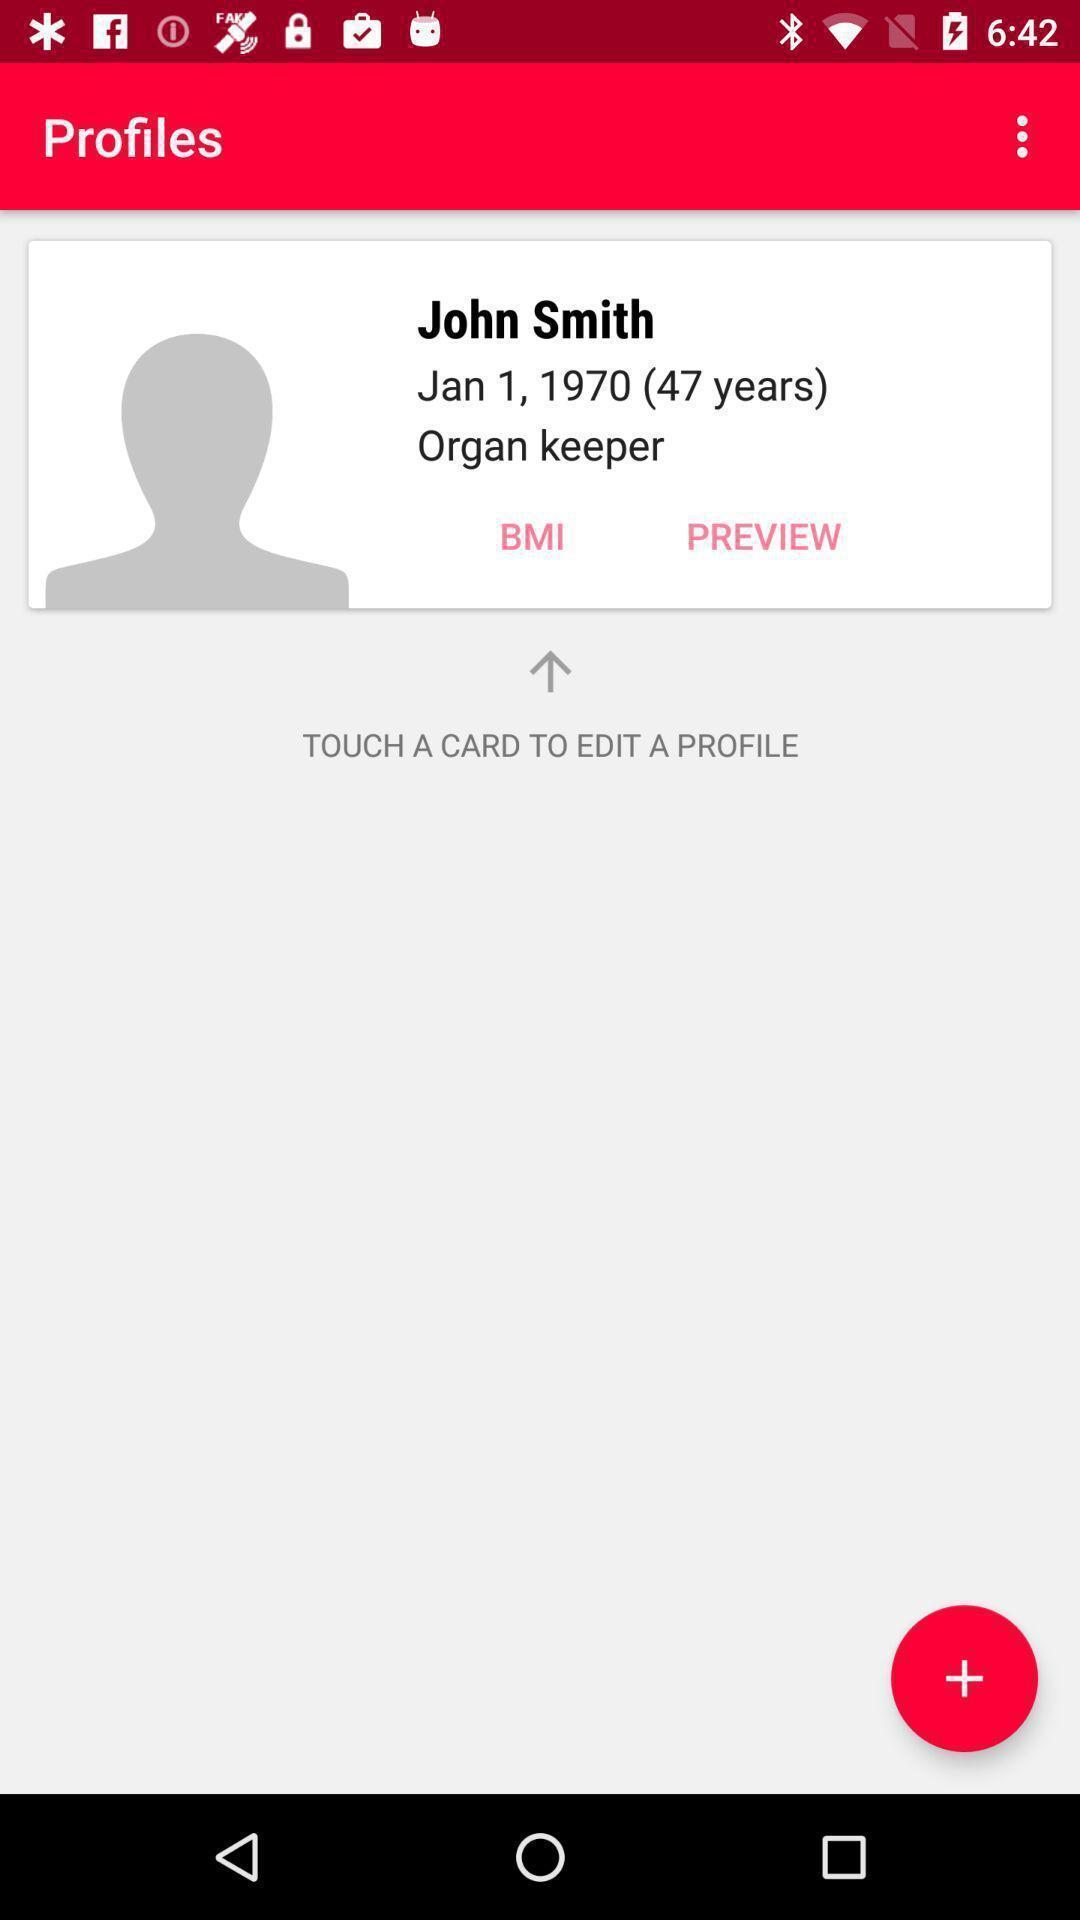What details can you identify in this image? Page shows the profile of the user for edit option. 